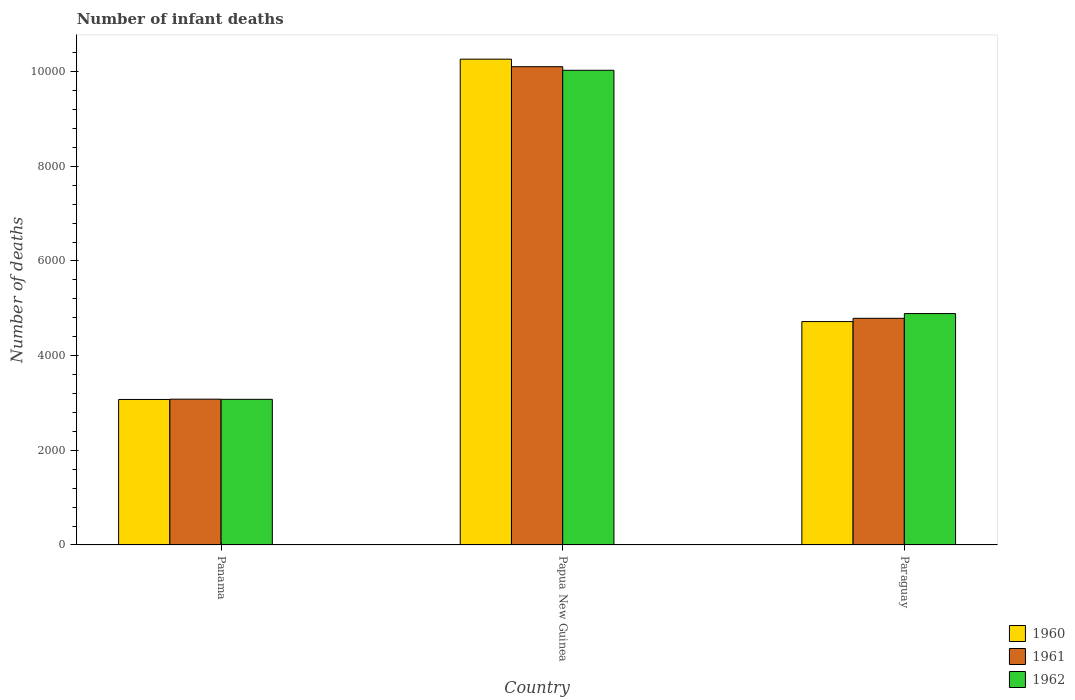How many different coloured bars are there?
Offer a terse response. 3. Are the number of bars per tick equal to the number of legend labels?
Your answer should be compact. Yes. Are the number of bars on each tick of the X-axis equal?
Make the answer very short. Yes. How many bars are there on the 1st tick from the left?
Give a very brief answer. 3. What is the label of the 1st group of bars from the left?
Provide a short and direct response. Panama. What is the number of infant deaths in 1961 in Paraguay?
Offer a terse response. 4789. Across all countries, what is the maximum number of infant deaths in 1960?
Your answer should be very brief. 1.03e+04. Across all countries, what is the minimum number of infant deaths in 1962?
Offer a terse response. 3077. In which country was the number of infant deaths in 1962 maximum?
Keep it short and to the point. Papua New Guinea. In which country was the number of infant deaths in 1961 minimum?
Make the answer very short. Panama. What is the total number of infant deaths in 1960 in the graph?
Your answer should be very brief. 1.81e+04. What is the difference between the number of infant deaths in 1960 in Papua New Guinea and that in Paraguay?
Give a very brief answer. 5545. What is the difference between the number of infant deaths in 1961 in Papua New Guinea and the number of infant deaths in 1962 in Paraguay?
Make the answer very short. 5217. What is the average number of infant deaths in 1962 per country?
Provide a short and direct response. 5998.67. What is the difference between the number of infant deaths of/in 1962 and number of infant deaths of/in 1960 in Papua New Guinea?
Offer a terse response. -235. In how many countries, is the number of infant deaths in 1960 greater than 8000?
Keep it short and to the point. 1. What is the ratio of the number of infant deaths in 1960 in Panama to that in Paraguay?
Provide a short and direct response. 0.65. Is the difference between the number of infant deaths in 1962 in Papua New Guinea and Paraguay greater than the difference between the number of infant deaths in 1960 in Papua New Guinea and Paraguay?
Your answer should be very brief. No. What is the difference between the highest and the second highest number of infant deaths in 1961?
Keep it short and to the point. -7026. What is the difference between the highest and the lowest number of infant deaths in 1961?
Make the answer very short. 7026. In how many countries, is the number of infant deaths in 1960 greater than the average number of infant deaths in 1960 taken over all countries?
Give a very brief answer. 1. Is the sum of the number of infant deaths in 1962 in Panama and Paraguay greater than the maximum number of infant deaths in 1960 across all countries?
Offer a very short reply. No. What does the 2nd bar from the left in Panama represents?
Provide a succinct answer. 1961. Is it the case that in every country, the sum of the number of infant deaths in 1961 and number of infant deaths in 1960 is greater than the number of infant deaths in 1962?
Make the answer very short. Yes. How many countries are there in the graph?
Offer a terse response. 3. What is the difference between two consecutive major ticks on the Y-axis?
Provide a short and direct response. 2000. Does the graph contain any zero values?
Ensure brevity in your answer.  No. Where does the legend appear in the graph?
Offer a very short reply. Bottom right. How are the legend labels stacked?
Ensure brevity in your answer.  Vertical. What is the title of the graph?
Offer a very short reply. Number of infant deaths. What is the label or title of the X-axis?
Your response must be concise. Country. What is the label or title of the Y-axis?
Your response must be concise. Number of deaths. What is the Number of deaths in 1960 in Panama?
Make the answer very short. 3074. What is the Number of deaths of 1961 in Panama?
Offer a terse response. 3080. What is the Number of deaths in 1962 in Panama?
Your response must be concise. 3077. What is the Number of deaths in 1960 in Papua New Guinea?
Offer a terse response. 1.03e+04. What is the Number of deaths of 1961 in Papua New Guinea?
Offer a very short reply. 1.01e+04. What is the Number of deaths of 1962 in Papua New Guinea?
Give a very brief answer. 1.00e+04. What is the Number of deaths in 1960 in Paraguay?
Keep it short and to the point. 4720. What is the Number of deaths of 1961 in Paraguay?
Provide a succinct answer. 4789. What is the Number of deaths in 1962 in Paraguay?
Provide a short and direct response. 4889. Across all countries, what is the maximum Number of deaths in 1960?
Provide a short and direct response. 1.03e+04. Across all countries, what is the maximum Number of deaths in 1961?
Ensure brevity in your answer.  1.01e+04. Across all countries, what is the maximum Number of deaths in 1962?
Your answer should be very brief. 1.00e+04. Across all countries, what is the minimum Number of deaths of 1960?
Your answer should be very brief. 3074. Across all countries, what is the minimum Number of deaths of 1961?
Your response must be concise. 3080. Across all countries, what is the minimum Number of deaths of 1962?
Provide a short and direct response. 3077. What is the total Number of deaths of 1960 in the graph?
Keep it short and to the point. 1.81e+04. What is the total Number of deaths in 1961 in the graph?
Ensure brevity in your answer.  1.80e+04. What is the total Number of deaths in 1962 in the graph?
Provide a short and direct response. 1.80e+04. What is the difference between the Number of deaths in 1960 in Panama and that in Papua New Guinea?
Your answer should be compact. -7191. What is the difference between the Number of deaths in 1961 in Panama and that in Papua New Guinea?
Your answer should be compact. -7026. What is the difference between the Number of deaths in 1962 in Panama and that in Papua New Guinea?
Make the answer very short. -6953. What is the difference between the Number of deaths in 1960 in Panama and that in Paraguay?
Offer a terse response. -1646. What is the difference between the Number of deaths in 1961 in Panama and that in Paraguay?
Offer a terse response. -1709. What is the difference between the Number of deaths of 1962 in Panama and that in Paraguay?
Keep it short and to the point. -1812. What is the difference between the Number of deaths of 1960 in Papua New Guinea and that in Paraguay?
Ensure brevity in your answer.  5545. What is the difference between the Number of deaths in 1961 in Papua New Guinea and that in Paraguay?
Offer a very short reply. 5317. What is the difference between the Number of deaths of 1962 in Papua New Guinea and that in Paraguay?
Your answer should be compact. 5141. What is the difference between the Number of deaths in 1960 in Panama and the Number of deaths in 1961 in Papua New Guinea?
Offer a very short reply. -7032. What is the difference between the Number of deaths in 1960 in Panama and the Number of deaths in 1962 in Papua New Guinea?
Provide a succinct answer. -6956. What is the difference between the Number of deaths in 1961 in Panama and the Number of deaths in 1962 in Papua New Guinea?
Provide a short and direct response. -6950. What is the difference between the Number of deaths in 1960 in Panama and the Number of deaths in 1961 in Paraguay?
Your answer should be very brief. -1715. What is the difference between the Number of deaths of 1960 in Panama and the Number of deaths of 1962 in Paraguay?
Ensure brevity in your answer.  -1815. What is the difference between the Number of deaths of 1961 in Panama and the Number of deaths of 1962 in Paraguay?
Provide a short and direct response. -1809. What is the difference between the Number of deaths of 1960 in Papua New Guinea and the Number of deaths of 1961 in Paraguay?
Give a very brief answer. 5476. What is the difference between the Number of deaths in 1960 in Papua New Guinea and the Number of deaths in 1962 in Paraguay?
Give a very brief answer. 5376. What is the difference between the Number of deaths in 1961 in Papua New Guinea and the Number of deaths in 1962 in Paraguay?
Make the answer very short. 5217. What is the average Number of deaths of 1960 per country?
Offer a terse response. 6019.67. What is the average Number of deaths of 1961 per country?
Give a very brief answer. 5991.67. What is the average Number of deaths in 1962 per country?
Your answer should be very brief. 5998.67. What is the difference between the Number of deaths of 1960 and Number of deaths of 1961 in Panama?
Offer a terse response. -6. What is the difference between the Number of deaths of 1960 and Number of deaths of 1962 in Panama?
Give a very brief answer. -3. What is the difference between the Number of deaths in 1960 and Number of deaths in 1961 in Papua New Guinea?
Give a very brief answer. 159. What is the difference between the Number of deaths in 1960 and Number of deaths in 1962 in Papua New Guinea?
Provide a short and direct response. 235. What is the difference between the Number of deaths of 1960 and Number of deaths of 1961 in Paraguay?
Your answer should be compact. -69. What is the difference between the Number of deaths of 1960 and Number of deaths of 1962 in Paraguay?
Offer a terse response. -169. What is the difference between the Number of deaths in 1961 and Number of deaths in 1962 in Paraguay?
Provide a succinct answer. -100. What is the ratio of the Number of deaths of 1960 in Panama to that in Papua New Guinea?
Ensure brevity in your answer.  0.3. What is the ratio of the Number of deaths of 1961 in Panama to that in Papua New Guinea?
Offer a terse response. 0.3. What is the ratio of the Number of deaths in 1962 in Panama to that in Papua New Guinea?
Give a very brief answer. 0.31. What is the ratio of the Number of deaths in 1960 in Panama to that in Paraguay?
Offer a terse response. 0.65. What is the ratio of the Number of deaths in 1961 in Panama to that in Paraguay?
Your answer should be very brief. 0.64. What is the ratio of the Number of deaths of 1962 in Panama to that in Paraguay?
Offer a very short reply. 0.63. What is the ratio of the Number of deaths in 1960 in Papua New Guinea to that in Paraguay?
Offer a very short reply. 2.17. What is the ratio of the Number of deaths in 1961 in Papua New Guinea to that in Paraguay?
Give a very brief answer. 2.11. What is the ratio of the Number of deaths in 1962 in Papua New Guinea to that in Paraguay?
Your response must be concise. 2.05. What is the difference between the highest and the second highest Number of deaths of 1960?
Give a very brief answer. 5545. What is the difference between the highest and the second highest Number of deaths in 1961?
Provide a short and direct response. 5317. What is the difference between the highest and the second highest Number of deaths in 1962?
Your answer should be very brief. 5141. What is the difference between the highest and the lowest Number of deaths in 1960?
Give a very brief answer. 7191. What is the difference between the highest and the lowest Number of deaths in 1961?
Provide a short and direct response. 7026. What is the difference between the highest and the lowest Number of deaths of 1962?
Your answer should be compact. 6953. 